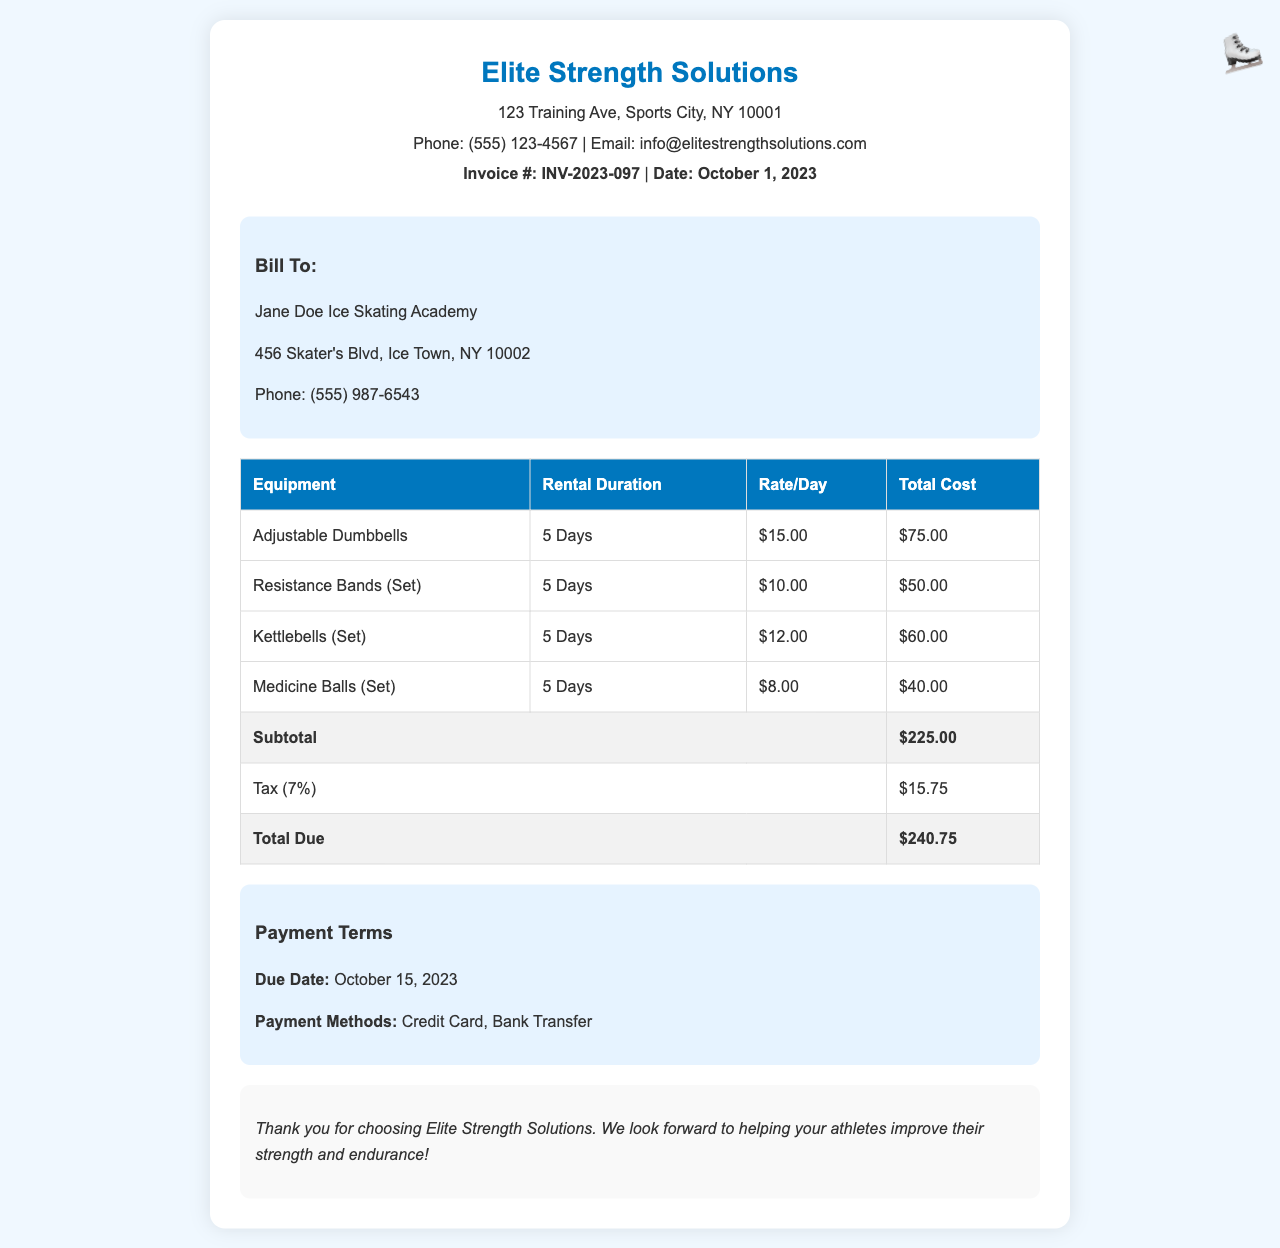What is the invoice number? The invoice number can be found in the header section of the document.
Answer: INV-2023-097 What is the total due amount? The total due amount is detailed in the table as the final cost after calculating subtotal and tax.
Answer: $240.75 What is the rental duration for the Adjustable Dumbbells? The rental duration for each piece of equipment is specified in the table.
Answer: 5 Days What is the tax rate applied to the invoice? The tax rate can be found in the subtotal section of the table.
Answer: 7% What equipment is rented for the lowest cost? The total cost for each piece of equipment allows us to identify which one is the least expensive.
Answer: Medicine Balls (Set) What is the due date for payment? The due date is specified in the payment terms section of the document.
Answer: October 15, 2023 How many different types of equipment are listed for rental? The number of equipment types can be counted from the table rows.
Answer: 4 What is the name of the client being billed? The client's name is listed in the client information section of the document.
Answer: Jane Doe Ice Skating Academy What are the payment methods accepted? The accepted payment methods are noted in the payment terms section.
Answer: Credit Card, Bank Transfer 